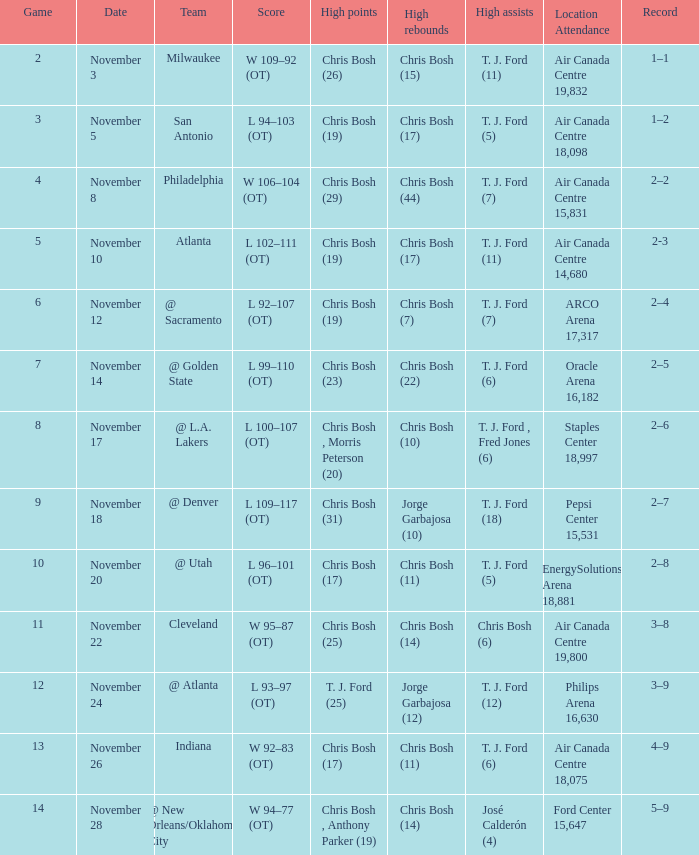What was the point tally of the game on november 12? L 92–107 (OT). 